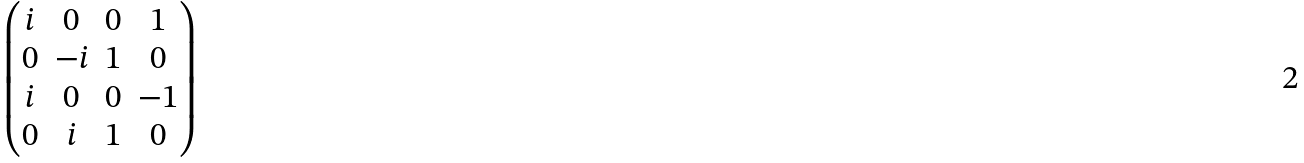<formula> <loc_0><loc_0><loc_500><loc_500>\begin{pmatrix} i & 0 & 0 & 1 \\ 0 & - i & 1 & 0 \\ i & 0 & 0 & - 1 \\ 0 & i & 1 & 0 \end{pmatrix}</formula> 